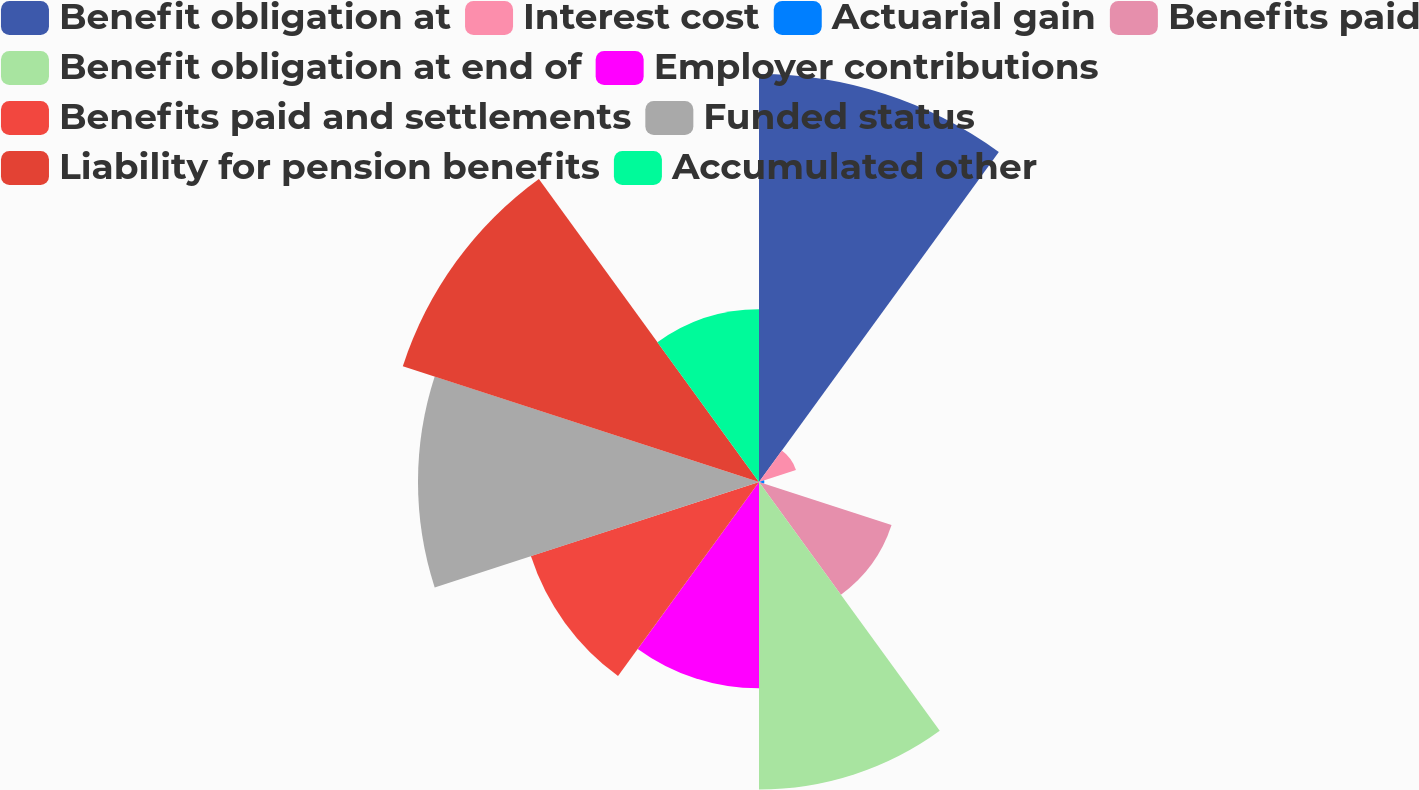Convert chart to OTSL. <chart><loc_0><loc_0><loc_500><loc_500><pie_chart><fcel>Benefit obligation at<fcel>Interest cost<fcel>Actuarial gain<fcel>Benefits paid<fcel>Benefit obligation at end of<fcel>Employer contributions<fcel>Benefits paid and settlements<fcel>Funded status<fcel>Liability for pension benefits<fcel>Accumulated other<nl><fcel>18.27%<fcel>1.74%<fcel>0.24%<fcel>6.24%<fcel>13.77%<fcel>9.24%<fcel>10.74%<fcel>15.27%<fcel>16.77%<fcel>7.74%<nl></chart> 